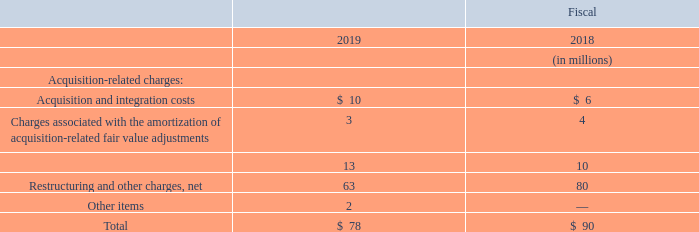Operating income in the Industrial Solutions segment increased $78 million in fiscal 2019 from fiscal 2018. The Industrial Solutions segment’s operating income included the following:
Excluding these items, operating income increased in fiscal 2019 primarily as a result of higher volume and improved manufacturing productivity.
What was the change in Operating income in the Industrial Solutions segment in 2019? Increased $78 million. Why did operating income increase in fiscal 2019? Primarily as a result of higher volume and improved manufacturing productivity. For which years was the operating income in the Industrial Solutions segment calculated? 2019, 2018. In which year was Acquisition and integration costs larger? 10>6
Answer: 2019. What was the change in Acquisition and integration costs in 2019 from 2018?
Answer scale should be: million. 10-6
Answer: 4. What was the percentage change in Acquisition and integration costs in 2019 from 2018?
Answer scale should be: percent. (10-6)/6
Answer: 66.67. 